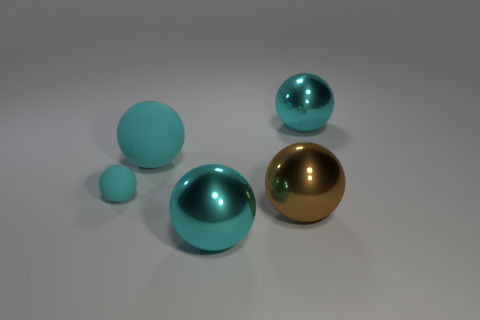What is the size of the sphere that is both in front of the large cyan matte sphere and behind the brown metallic object?
Make the answer very short. Small. There is a tiny object that is the same shape as the large rubber thing; what is its material?
Your answer should be very brief. Rubber. What is the material of the large cyan object in front of the small matte object to the left of the brown thing?
Your answer should be compact. Metal. What number of rubber things are either big purple objects or brown spheres?
Your response must be concise. 0. The matte thing in front of the large cyan sphere that is to the left of the big cyan ball in front of the small matte sphere is what color?
Your response must be concise. Cyan. How many other objects are the same material as the brown thing?
Make the answer very short. 2. How many big things are either shiny spheres or cyan rubber objects?
Your answer should be very brief. 4. Are there an equal number of shiny objects to the left of the brown ball and large cyan spheres in front of the tiny rubber object?
Make the answer very short. Yes. What number of other things are there of the same color as the big matte sphere?
Make the answer very short. 3. There is a small thing; does it have the same color as the big shiny thing that is right of the large brown metallic thing?
Provide a succinct answer. Yes. 